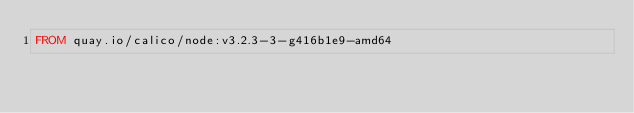<code> <loc_0><loc_0><loc_500><loc_500><_Dockerfile_>FROM quay.io/calico/node:v3.2.3-3-g416b1e9-amd64
</code> 